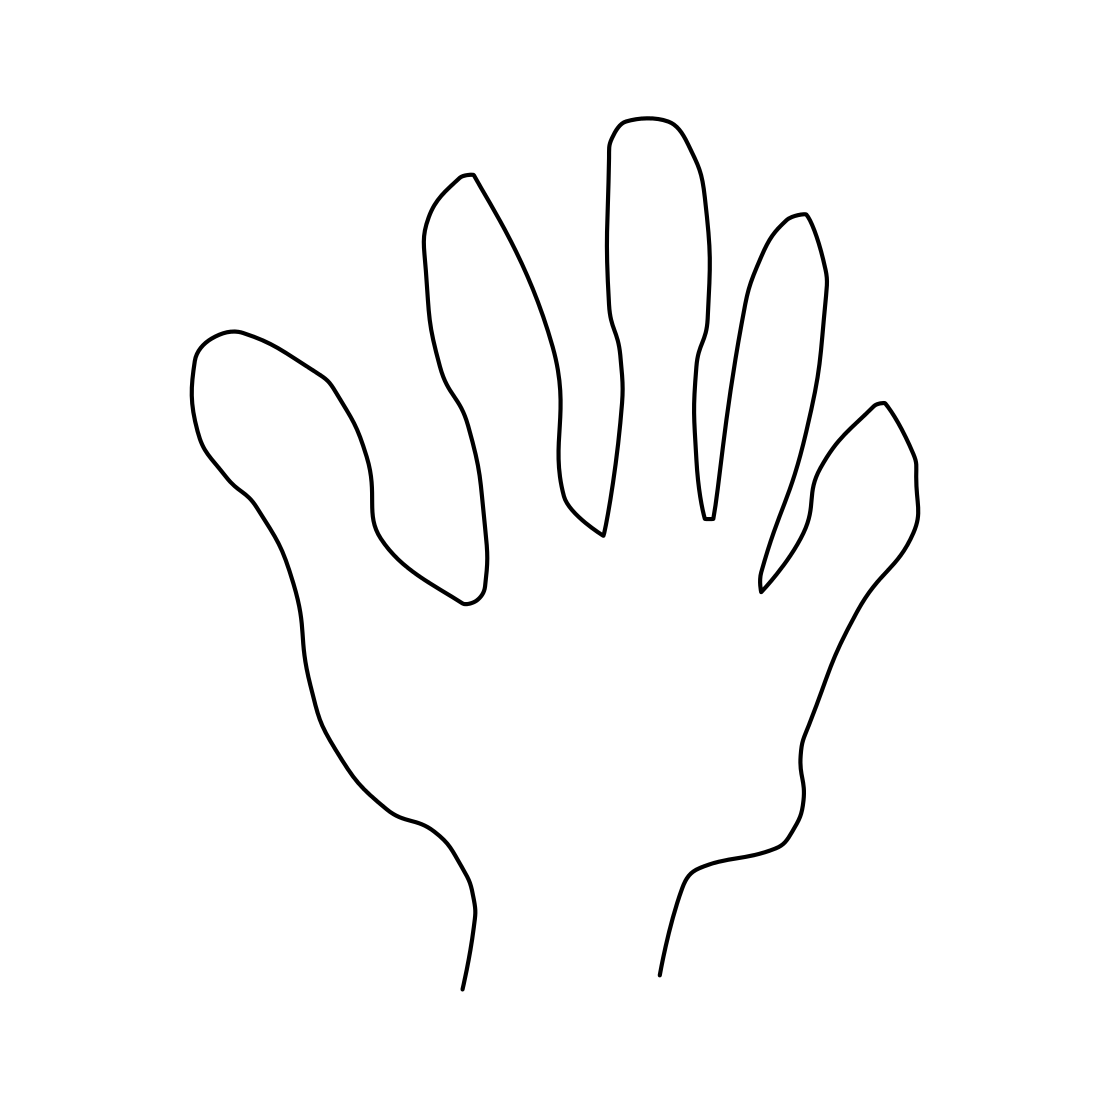Is there something missing from this drawing that you would usually find on a hand? The drawing omits the fine details inherent to a human hand, such as knuckles, fingernails, and skin textures like wrinkles or creases. The lack of these details gives the drawing a clean and abstract aesthetic, which focuses on the hand's outline and form rather than its intricate features. 